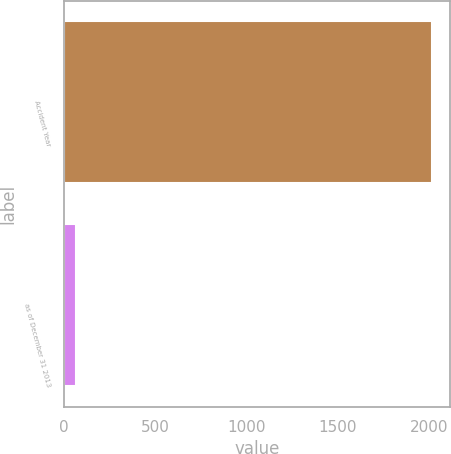<chart> <loc_0><loc_0><loc_500><loc_500><bar_chart><fcel>Accident Year<fcel>as of December 31 2013<nl><fcel>2013<fcel>67.8<nl></chart> 